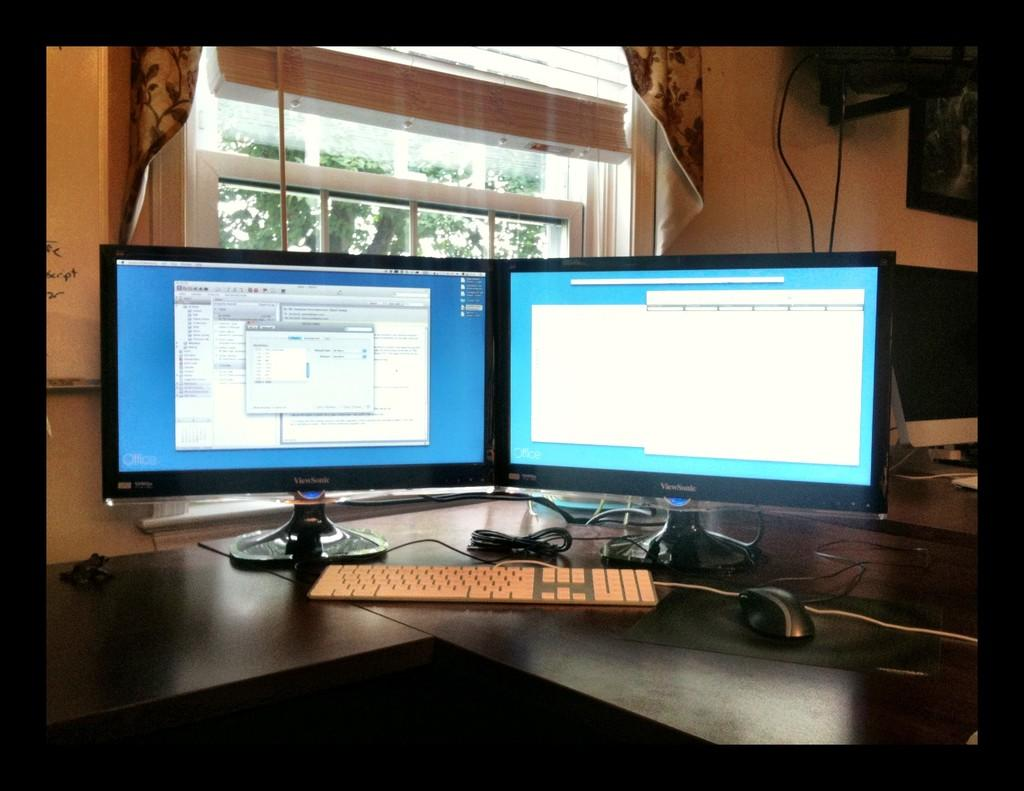<image>
Relay a brief, clear account of the picture shown. A pair of Viewsonic monitors sitting on top of a dark wood corner desk. 